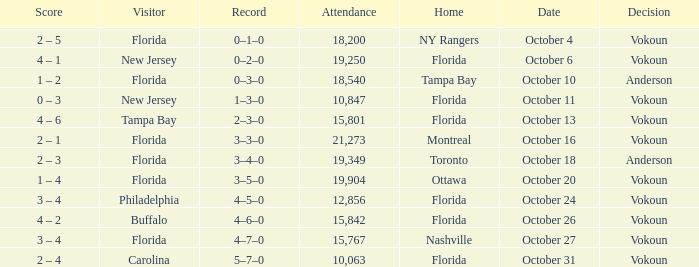Which team won when the visitor was Carolina? Vokoun. 